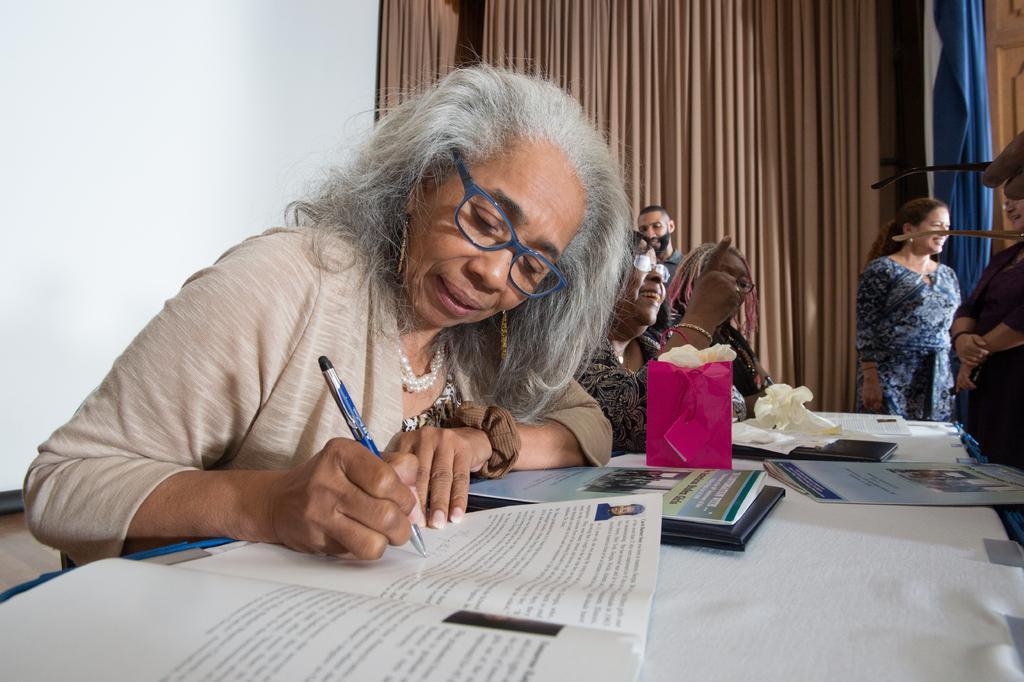In one or two sentences, can you explain what this image depicts? In this picture we can see a woman holding a pen and writing in the book. There are a few books, box and a tissue paper on the table. There are two women sitting on the chair. We can see a wooden object on the right side. There is a blue curtain, cream curtain and a wall is visible in the background. 